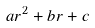Convert formula to latex. <formula><loc_0><loc_0><loc_500><loc_500>a r ^ { 2 } + b r + c</formula> 